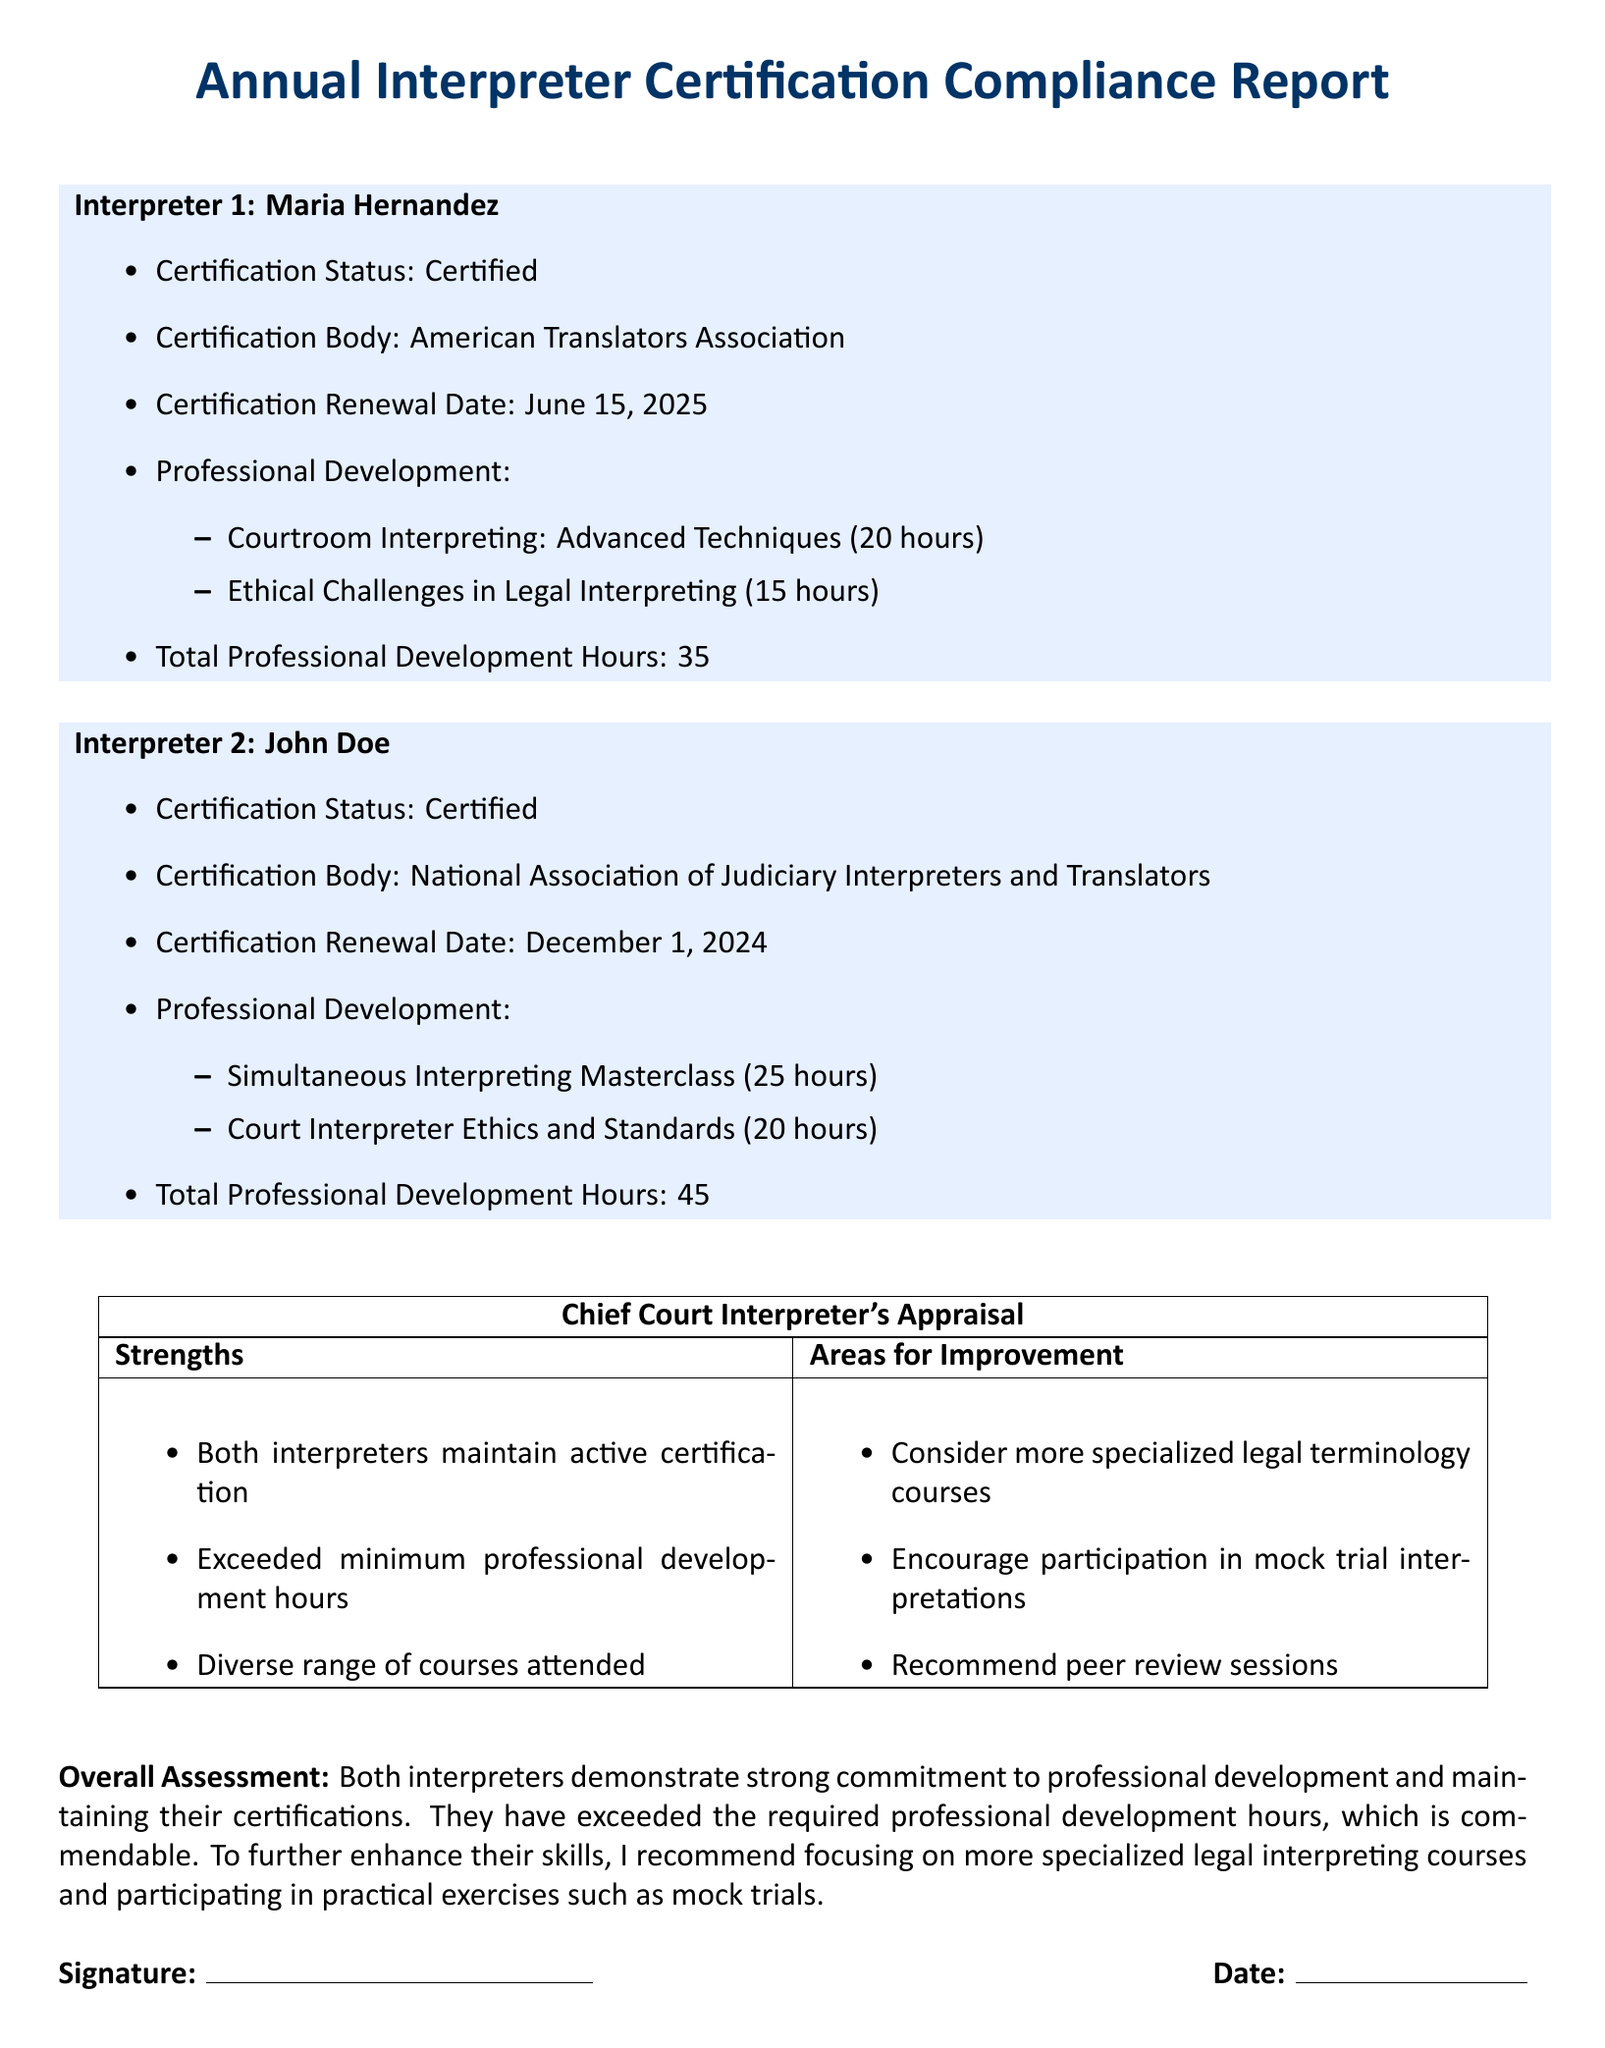What is the certification status of Maria Hernandez? The certification status is explicitly stated in the document under Maria Hernandez's details.
Answer: Certified What is the renewal date for John Doe's certification? The renewal date for John Doe is mentioned clearly in the report.
Answer: December 1, 2024 How many professional development hours did Maria Hernandez complete? The total professional development hours for Maria Hernandez are listed in her section of the report.
Answer: 35 What is one of the strengths noted in the appraisal? Strengths are identified in the Chief Court Interpreter's appraisal section, which includes specific points about the interpreters.
Answer: Exceeded minimum professional development hours Which organization certified John Doe? The certification body for John Doe is specifically mentioned in the document.
Answer: National Association of Judiciary Interpreters and Translators What type of courses did the Chief Court Interpreter recommend for improvement? The areas for improvement include suggestions for specific types of courses to enhance skills.
Answer: Specialized legal terminology courses What is the total professional development hours for John Doe? The total professional development hours for John Doe are clearly stated in his section.
Answer: 45 What is the overall assessment of the interpreters? The overall assessment summarizes the performance of the interpreters regarding their commitment and professional development.
Answer: Strong commitment to professional development Which interpreter attended the course on "Ethical Challenges in Legal Interpreting"? This information is indicated in the professional development section of the document under Maria Hernandez's details.
Answer: Maria Hernandez 